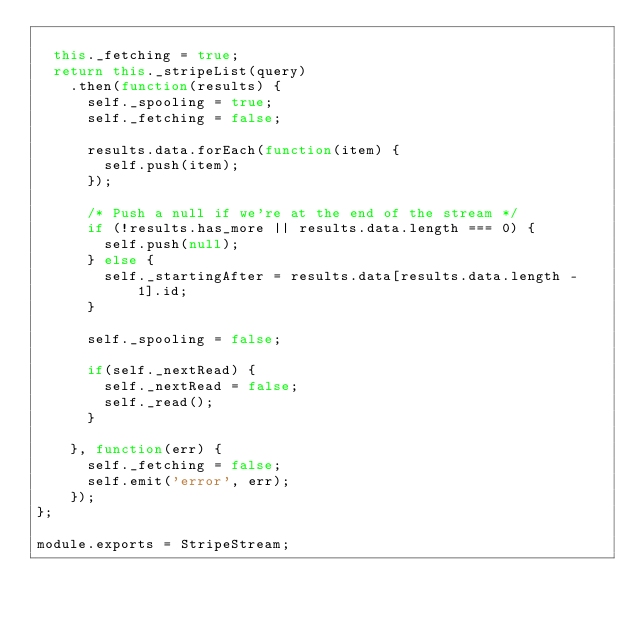Convert code to text. <code><loc_0><loc_0><loc_500><loc_500><_JavaScript_>
  this._fetching = true;
  return this._stripeList(query)
    .then(function(results) {
      self._spooling = true;
      self._fetching = false;

      results.data.forEach(function(item) {
        self.push(item);
      });

      /* Push a null if we're at the end of the stream */
      if (!results.has_more || results.data.length === 0) {
        self.push(null);
      } else {
        self._startingAfter = results.data[results.data.length - 1].id;
      }

      self._spooling = false;

      if(self._nextRead) {
        self._nextRead = false;
        self._read();
      }

    }, function(err) {
      self._fetching = false;
      self.emit('error', err);
    });
};

module.exports = StripeStream;

</code> 